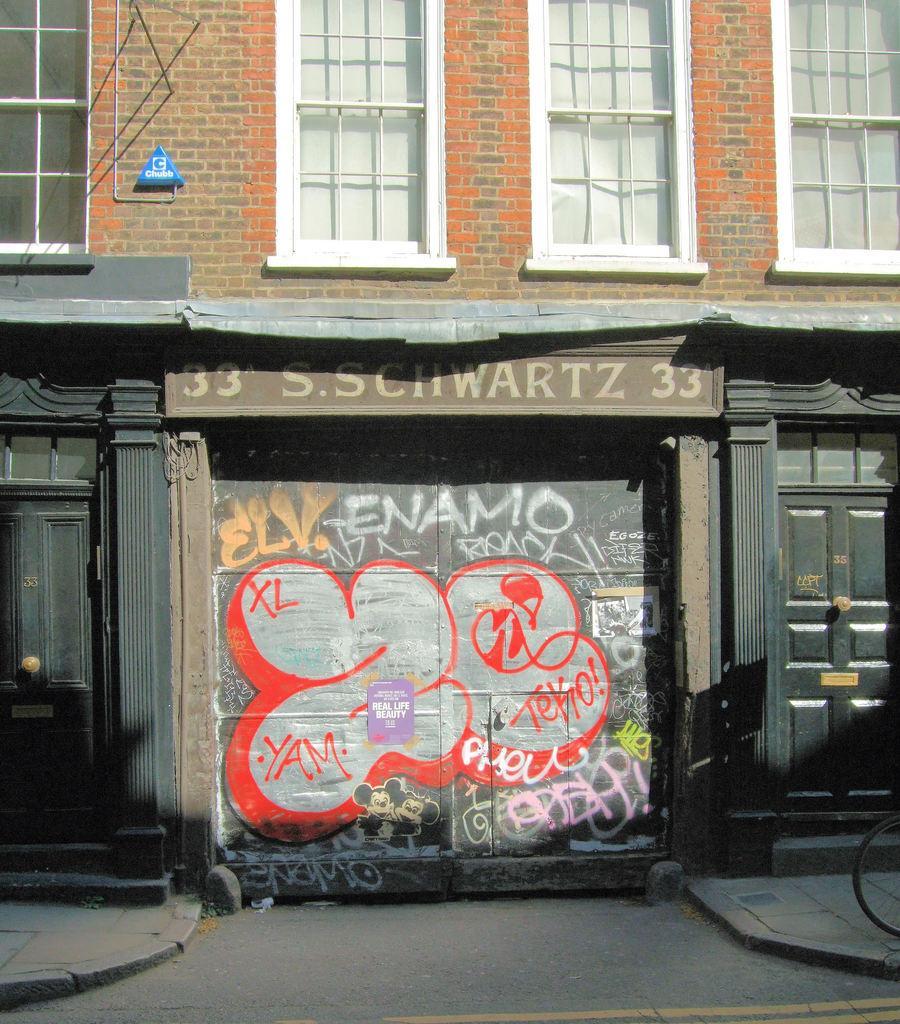How would you summarize this image in a sentence or two? In this image we can see a building. on building windows are there which are in white color. The doors of the building are in black color. 